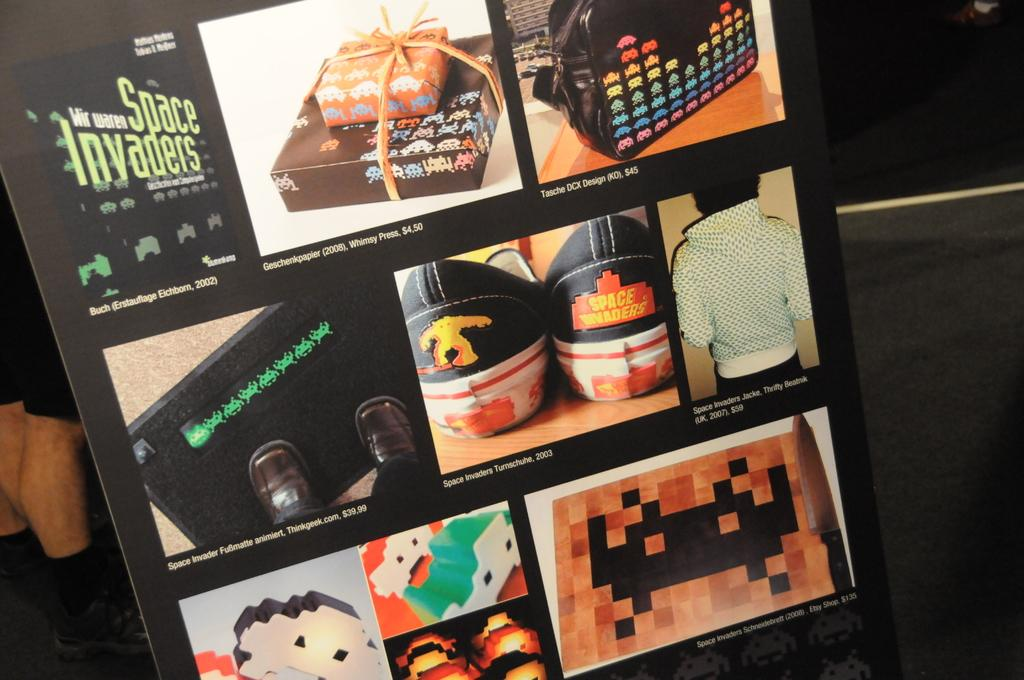<image>
Describe the image concisely. A poster of several pictures including space invaders. 